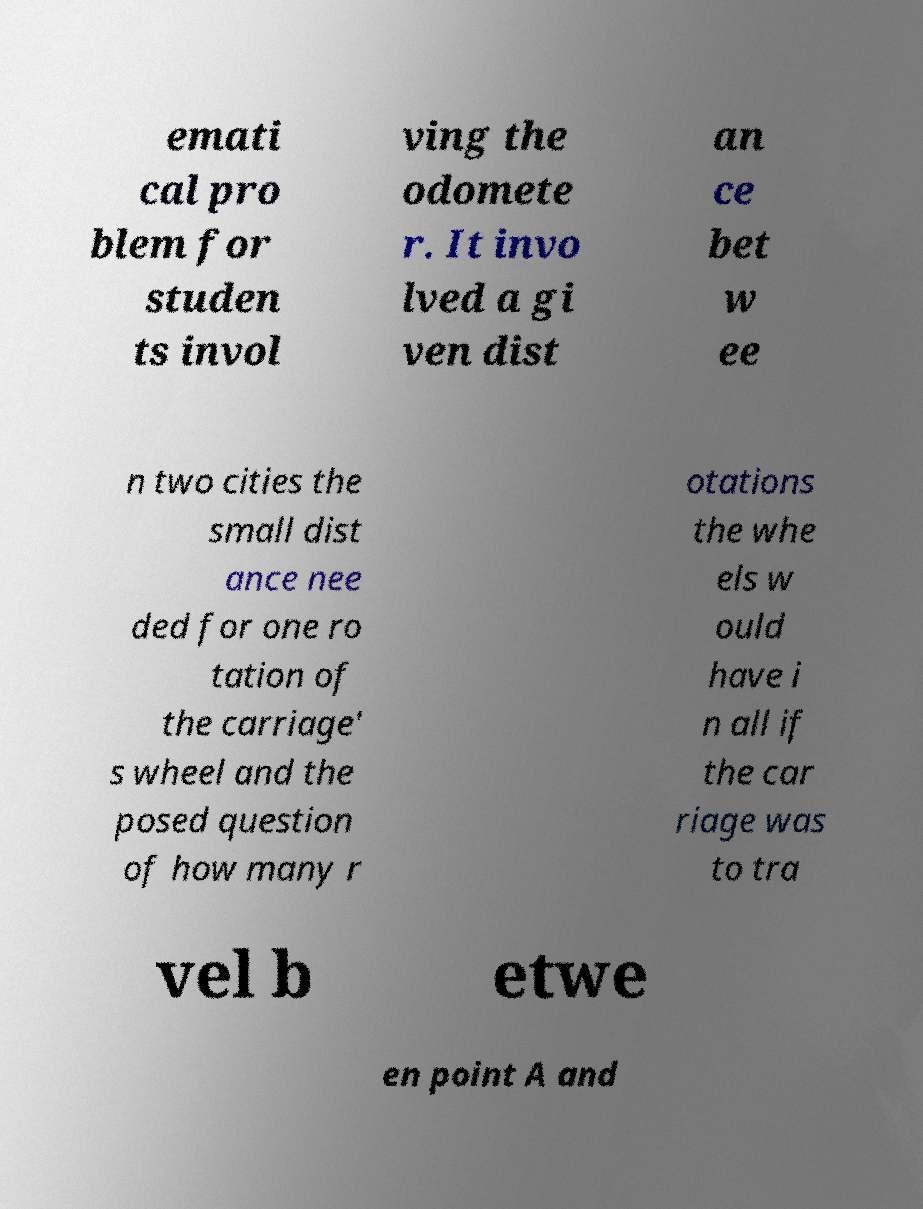Could you extract and type out the text from this image? emati cal pro blem for studen ts invol ving the odomete r. It invo lved a gi ven dist an ce bet w ee n two cities the small dist ance nee ded for one ro tation of the carriage' s wheel and the posed question of how many r otations the whe els w ould have i n all if the car riage was to tra vel b etwe en point A and 